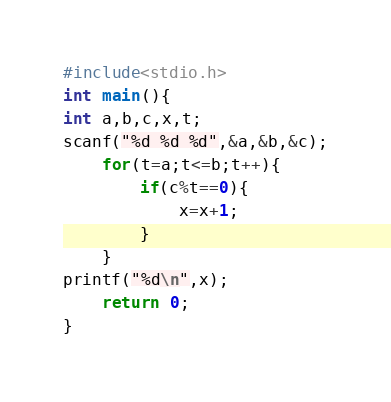Convert code to text. <code><loc_0><loc_0><loc_500><loc_500><_C_>#include<stdio.h>
int main(){
int a,b,c,x,t;
scanf("%d %d %d",&a,&b,&c);
	for(t=a;t<=b;t++){
		if(c%t==0){
			x=x+1;
		}
	}
printf("%d\n",x);
	return 0;
}</code> 